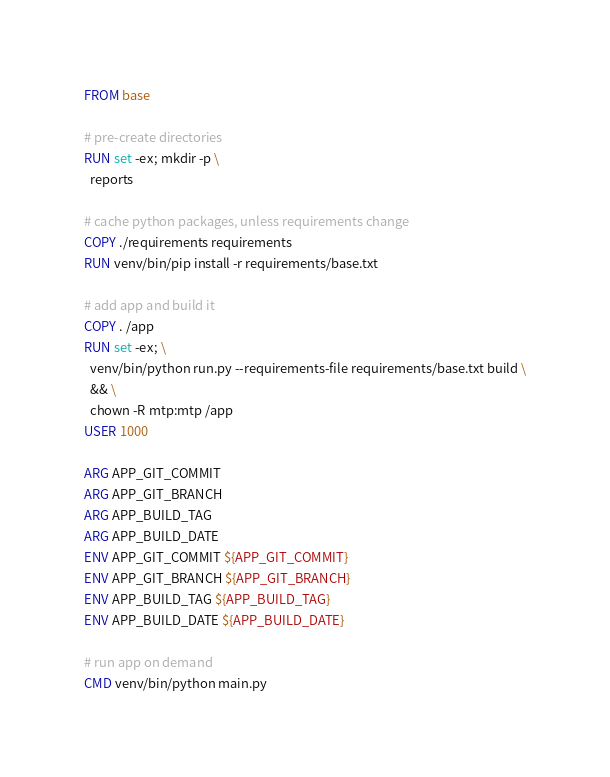Convert code to text. <code><loc_0><loc_0><loc_500><loc_500><_Dockerfile_>FROM base

# pre-create directories
RUN set -ex; mkdir -p \
  reports

# cache python packages, unless requirements change
COPY ./requirements requirements
RUN venv/bin/pip install -r requirements/base.txt

# add app and build it
COPY . /app
RUN set -ex; \
  venv/bin/python run.py --requirements-file requirements/base.txt build \
  && \
  chown -R mtp:mtp /app
USER 1000

ARG APP_GIT_COMMIT
ARG APP_GIT_BRANCH
ARG APP_BUILD_TAG
ARG APP_BUILD_DATE
ENV APP_GIT_COMMIT ${APP_GIT_COMMIT}
ENV APP_GIT_BRANCH ${APP_GIT_BRANCH}
ENV APP_BUILD_TAG ${APP_BUILD_TAG}
ENV APP_BUILD_DATE ${APP_BUILD_DATE}

# run app on demand
CMD venv/bin/python main.py
</code> 